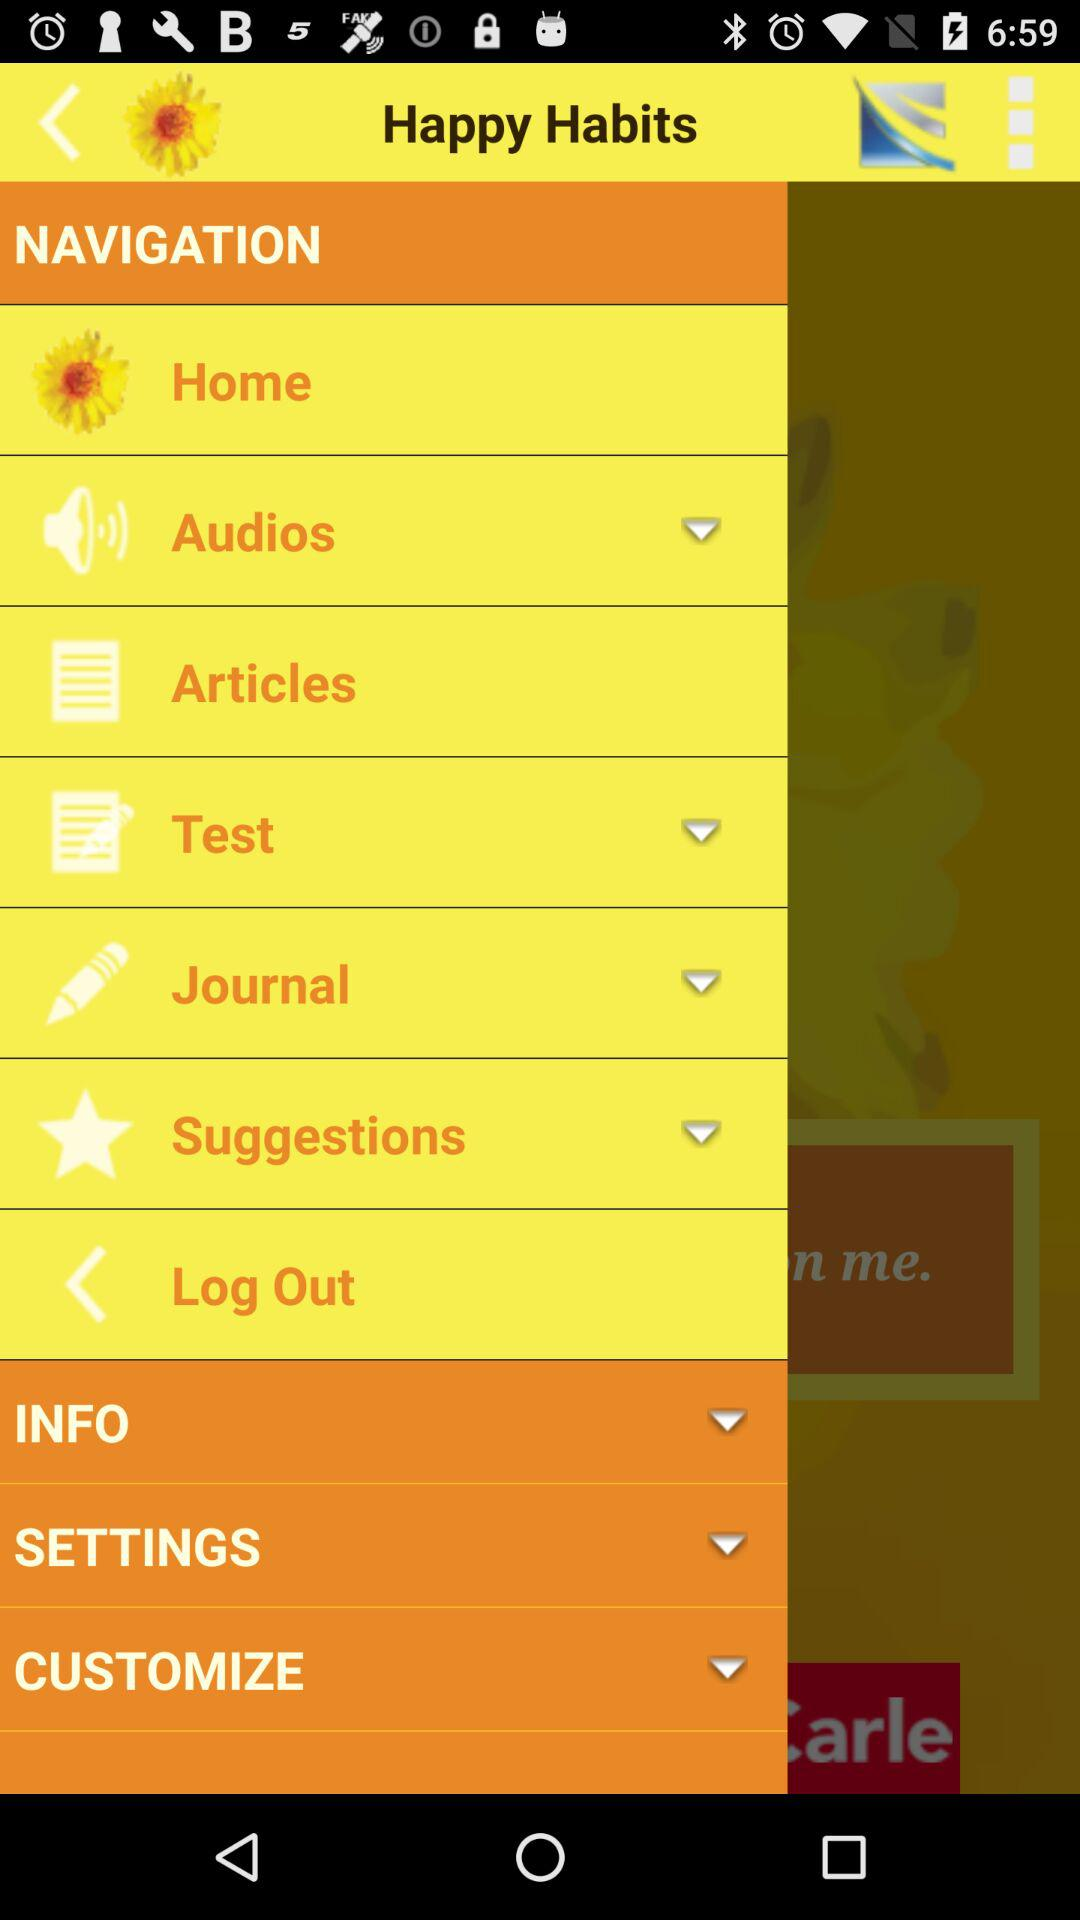What is the application name? The application name is "Happy Habits". 